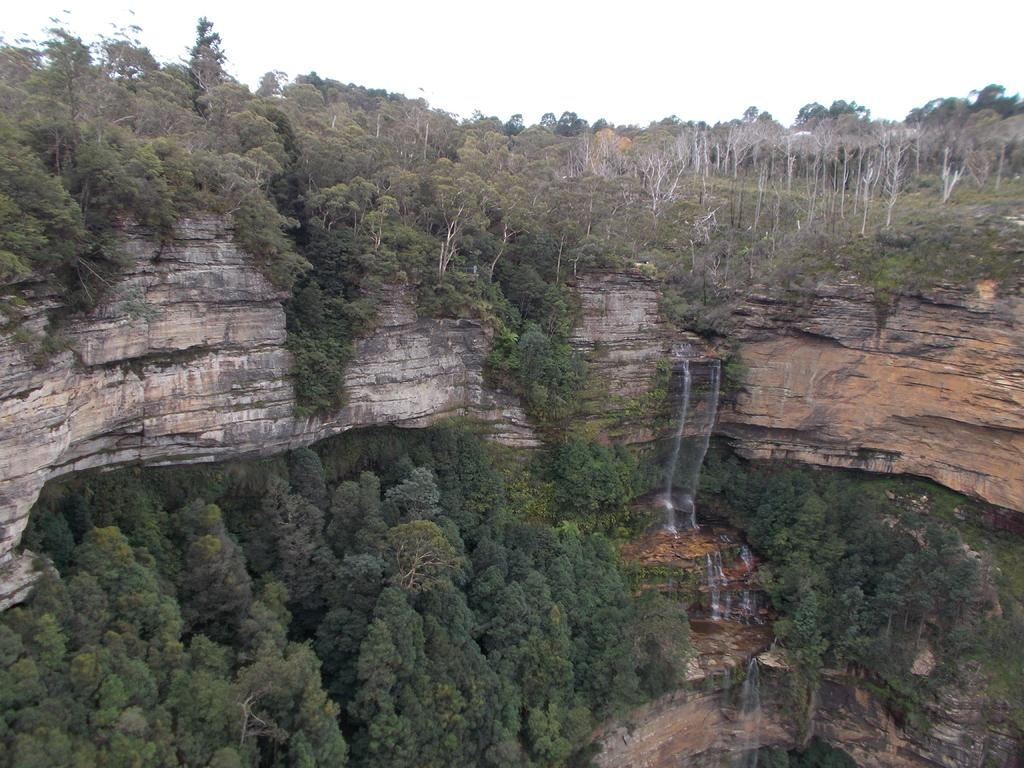What type of natural environment is depicted in the image? The image features many trees and mountains. What is the source of the water in the image? Water is flowing from the mountains in the image. What is the color of the sky in the background of the image? The sky is white in the background of the image. What type of dinner is being served in the image? There is no dinner present in the image; it features a natural landscape with trees, mountains, and flowing water. 